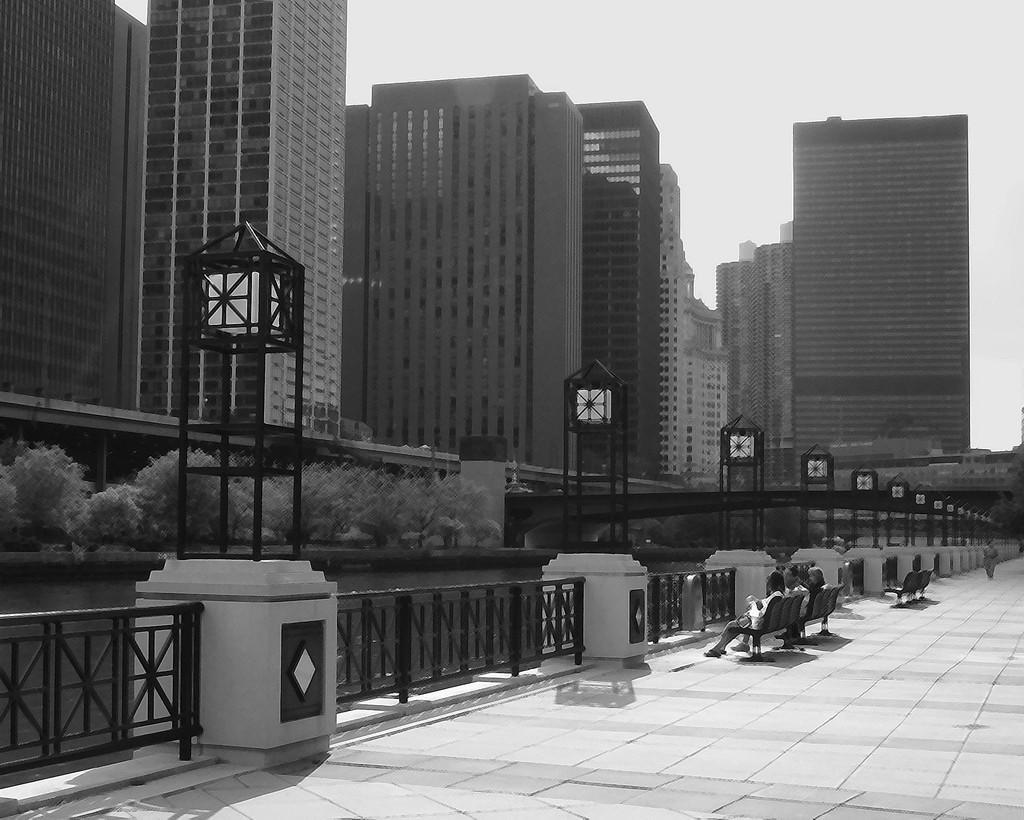Could you give a brief overview of what you see in this image? It is a black and white picture. In the center of the image we can see a few people are sitting on the benches. In the background, we can see the sky, buildings, water, fences, trees, one bridge and a few other objects. 